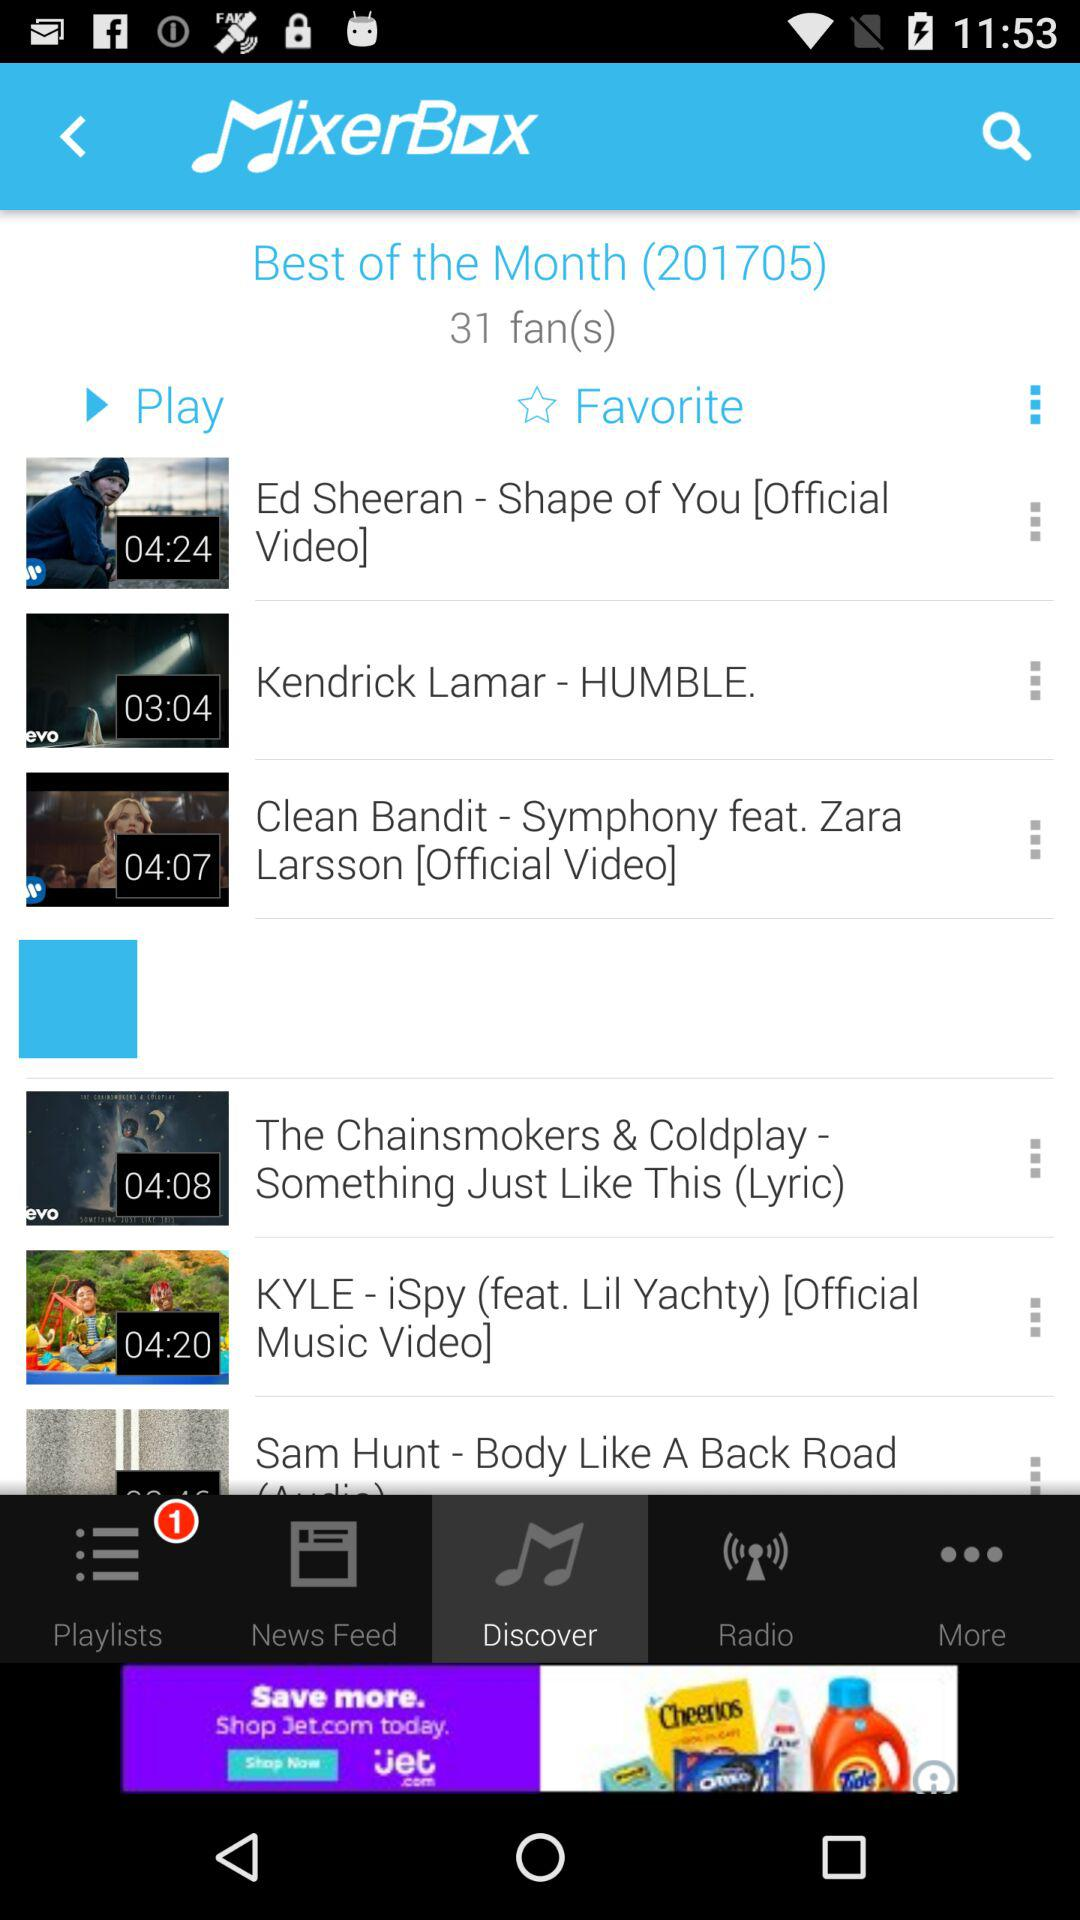What is the name of the singer of the song "Shape of You"? The name of the singer is Ed Sheeran. 